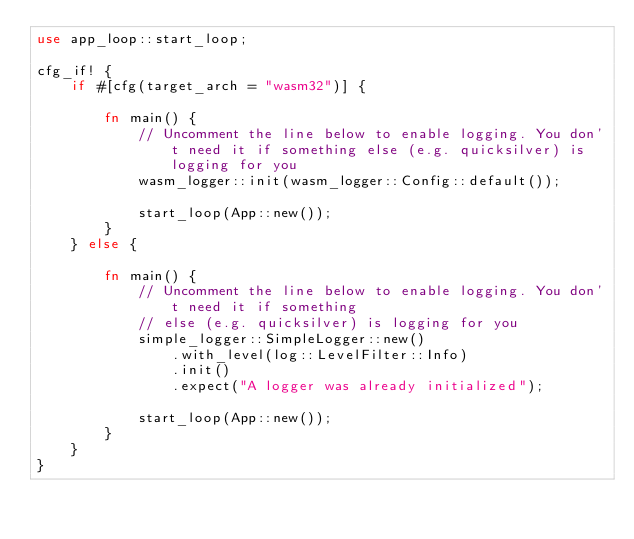Convert code to text. <code><loc_0><loc_0><loc_500><loc_500><_Rust_>use app_loop::start_loop;

cfg_if! {
    if #[cfg(target_arch = "wasm32")] {

        fn main() {
            // Uncomment the line below to enable logging. You don't need it if something else (e.g. quicksilver) is logging for you
            wasm_logger::init(wasm_logger::Config::default());

            start_loop(App::new());
        }
    } else {

        fn main() {
            // Uncomment the line below to enable logging. You don't need it if something
            // else (e.g. quicksilver) is logging for you
            simple_logger::SimpleLogger::new()
                .with_level(log::LevelFilter::Info)
                .init()
                .expect("A logger was already initialized");

            start_loop(App::new());
        }
    }
}
</code> 